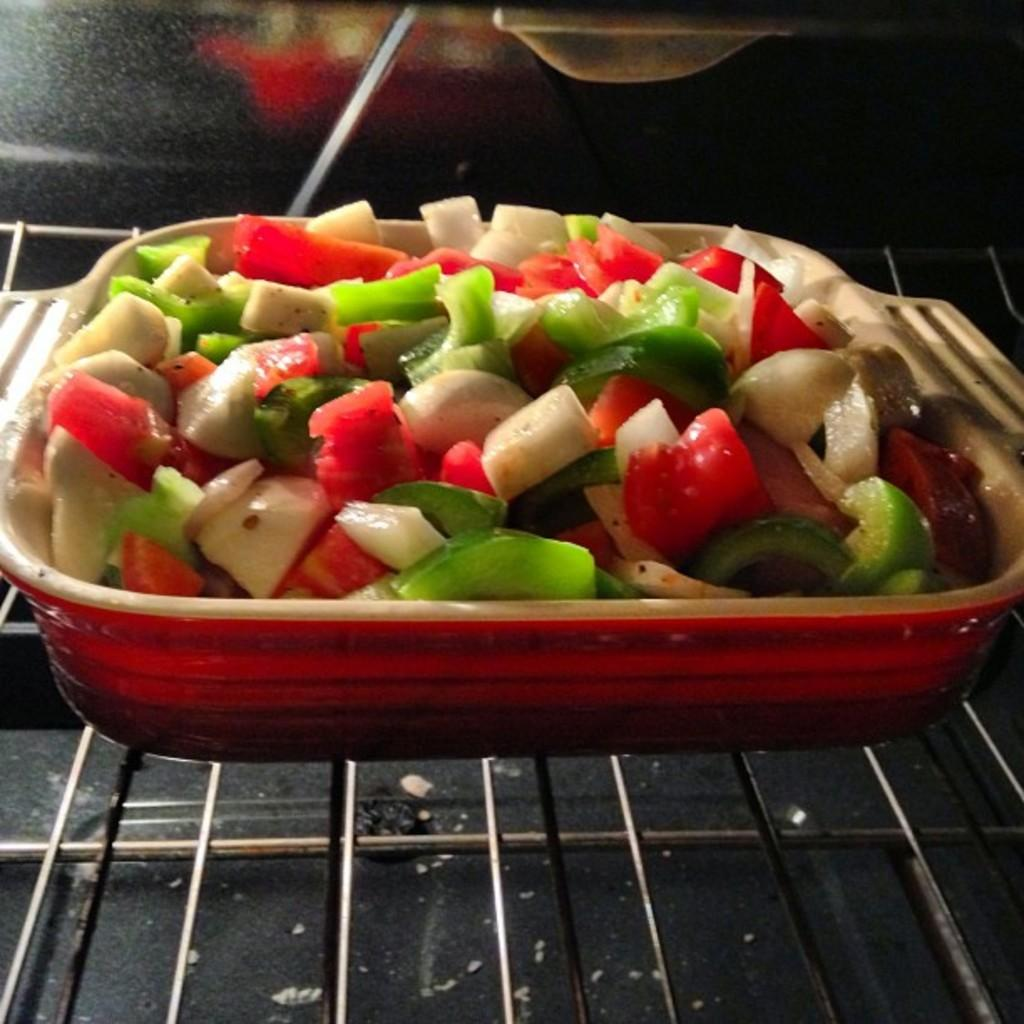What is in the bowl that is visible in the image? The bowl contains cut vegetables. Where is the bowl located in the image? The bowl is placed on a grill. How does the flesh appear on the vegetables in the image? There is no flesh present on the vegetables in the image, as the bowl contains cut vegetables, not meat. 